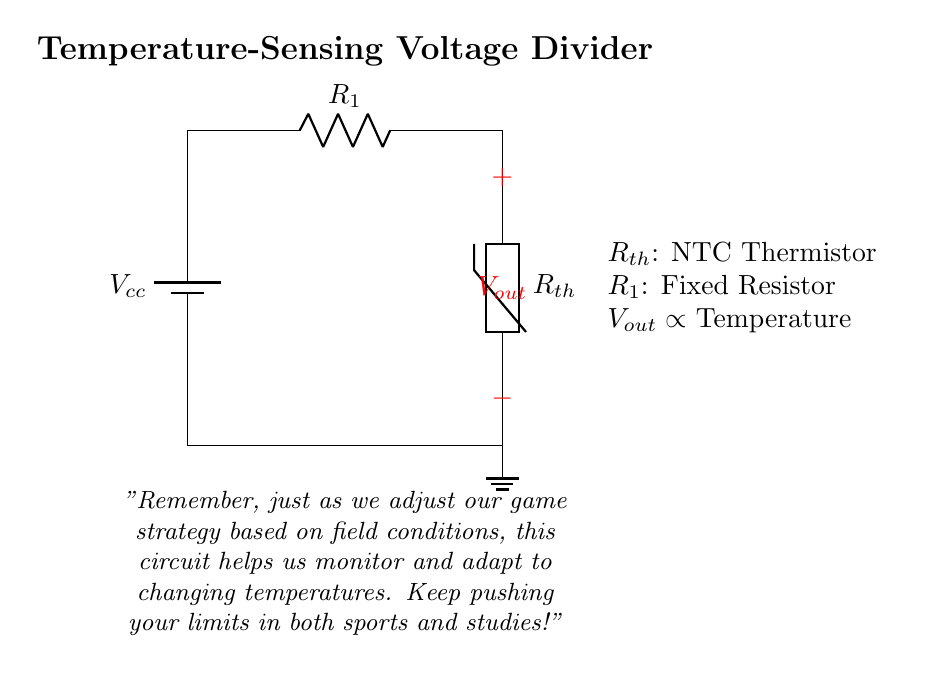What type of resistor is used in this circuit? The circuit features a thermistor, which is a type of resistor that changes resistance with temperature. The label on the circuit indicates it as Rth, denoting it as an NTC (Negative Temperature Coefficient) thermistor.
Answer: NTC thermistor What does Vout represent in the circuit? Vout is the output voltage measured across the thermistor, which varies inversely with the temperature due to the characteristics of the NTC thermistor. As temperature increases, the resistance decreases, which affects the voltage accordingly.
Answer: Output voltage What is the purpose of R1 in this voltage divider? R1 acts as a fixed resistor within the voltage divider, providing a reference resistance that allows the circuit to measure the output voltage based on the changes in the thermistor's resistance as temperature varies.
Answer: Reference resistance How does temperature affect Vout in this circuit? As temperature increases, the resistance of the NTC thermistor decreases, causing Vout to decrease as well given the relationship in voltage dividers. This creates a negative correlation between temperature and output voltage.
Answer: Decreases What are the two main components in this voltage divider? The two main components are the fixed resistor (R1) and the thermistor (Rth). These components are connected in series, creating a simple voltage divider that allows temperature measurements based on voltage changes.
Answer: R1 and Rth What is the overall function of this temperature-sensing circuit? The circuit is designed to monitor temperature conditions in the field by providing an output voltage (Vout) that is proportional to the temperature sensed by the NTC thermistor. It enables real-time temperature monitoring, which can be crucial for decision-making during outdoor activities.
Answer: Monitor temperature conditions 